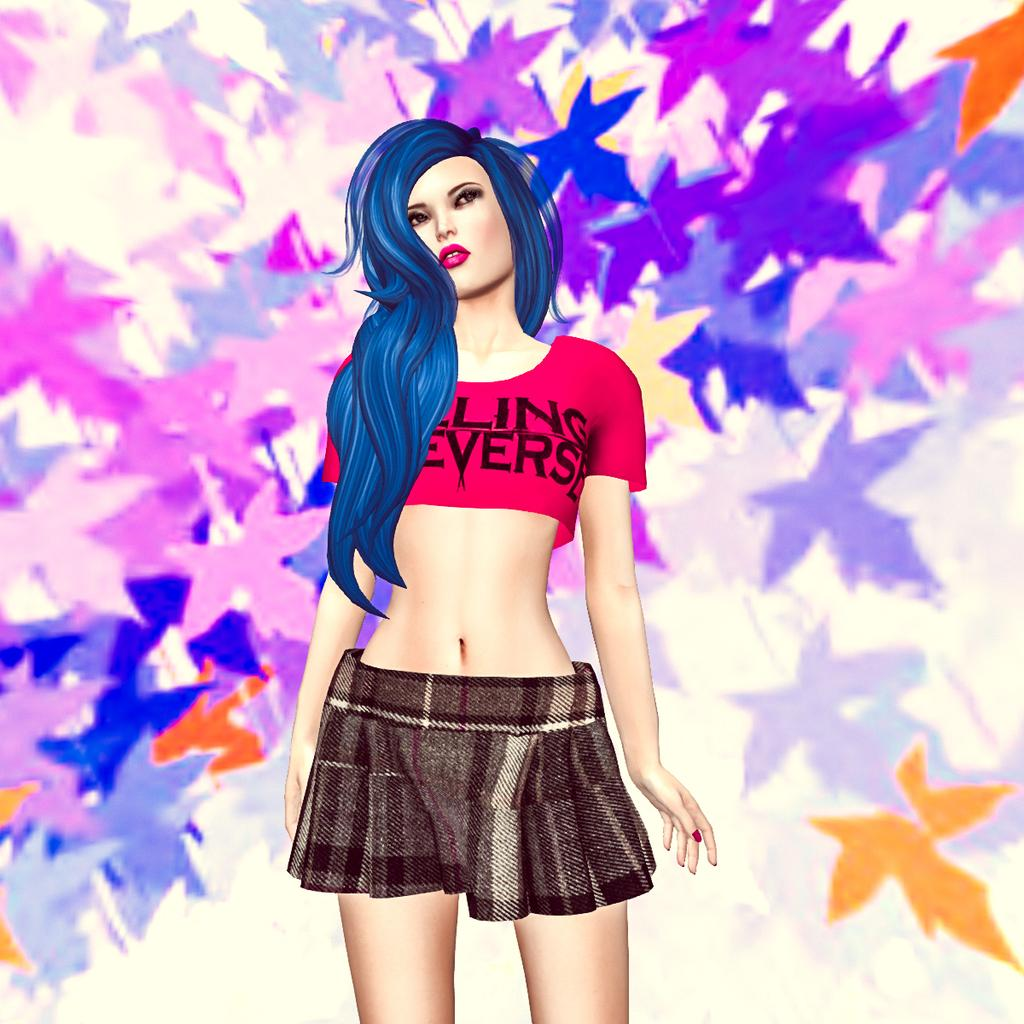<image>
Create a compact narrative representing the image presented. A digital art piece of a woman  wearing a shirt that has the letters ling on it. 